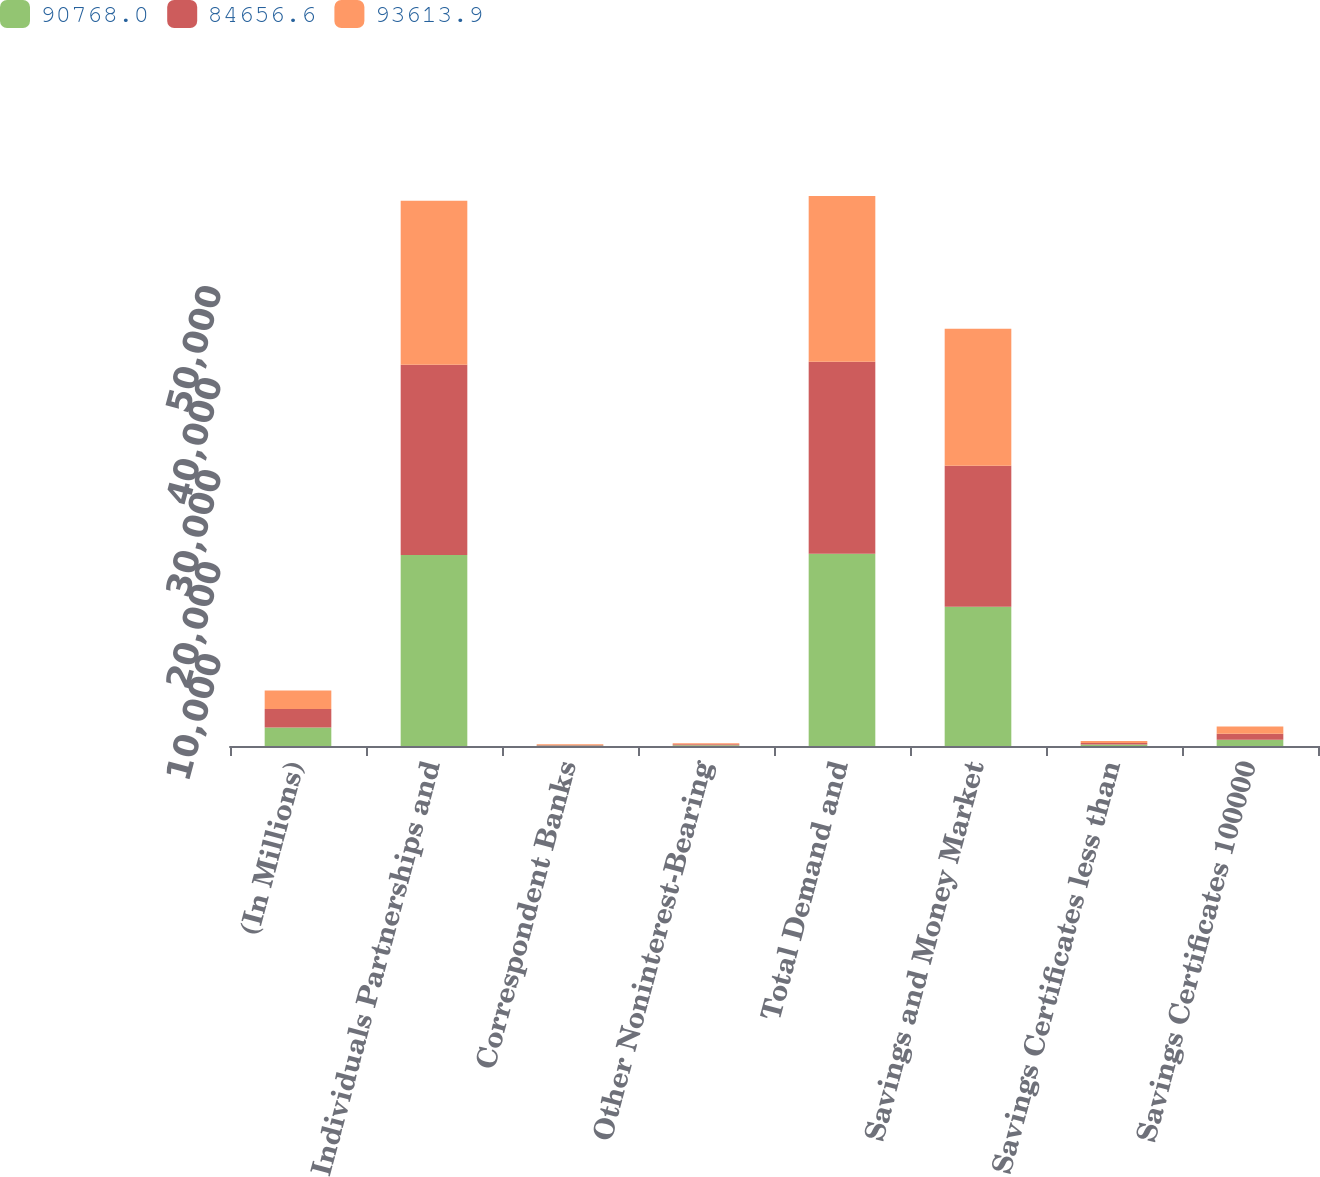Convert chart to OTSL. <chart><loc_0><loc_0><loc_500><loc_500><stacked_bar_chart><ecel><fcel>(In Millions)<fcel>Individuals Partnerships and<fcel>Correspondent Banks<fcel>Other Noninterest-Bearing<fcel>Total Demand and<fcel>Savings and Money Market<fcel>Savings Certificates less than<fcel>Savings Certificates 100000<nl><fcel>90768<fcel>2016<fcel>20764.8<fcel>58<fcel>76.3<fcel>20899.1<fcel>15142.4<fcel>150.9<fcel>672<nl><fcel>84656.6<fcel>2015<fcel>20684.9<fcel>59.8<fcel>124.6<fcel>20869.3<fcel>15306.9<fcel>175.9<fcel>669.9<nl><fcel>93613.9<fcel>2014<fcel>17816.4<fcel>78.9<fcel>111.6<fcel>18006.9<fcel>14904.4<fcel>209.1<fcel>767.6<nl></chart> 